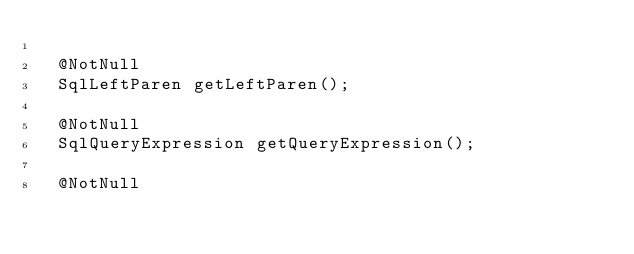<code> <loc_0><loc_0><loc_500><loc_500><_Java_>
  @NotNull
  SqlLeftParen getLeftParen();

  @NotNull
  SqlQueryExpression getQueryExpression();

  @NotNull</code> 